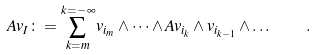<formula> <loc_0><loc_0><loc_500><loc_500>A v _ { I } \colon = \sum _ { k = m } ^ { k = - \infty } v _ { i _ { m } } \wedge \dots \wedge A v _ { i _ { k } } \wedge v _ { i _ { k - 1 } } \wedge \dots \quad .</formula> 